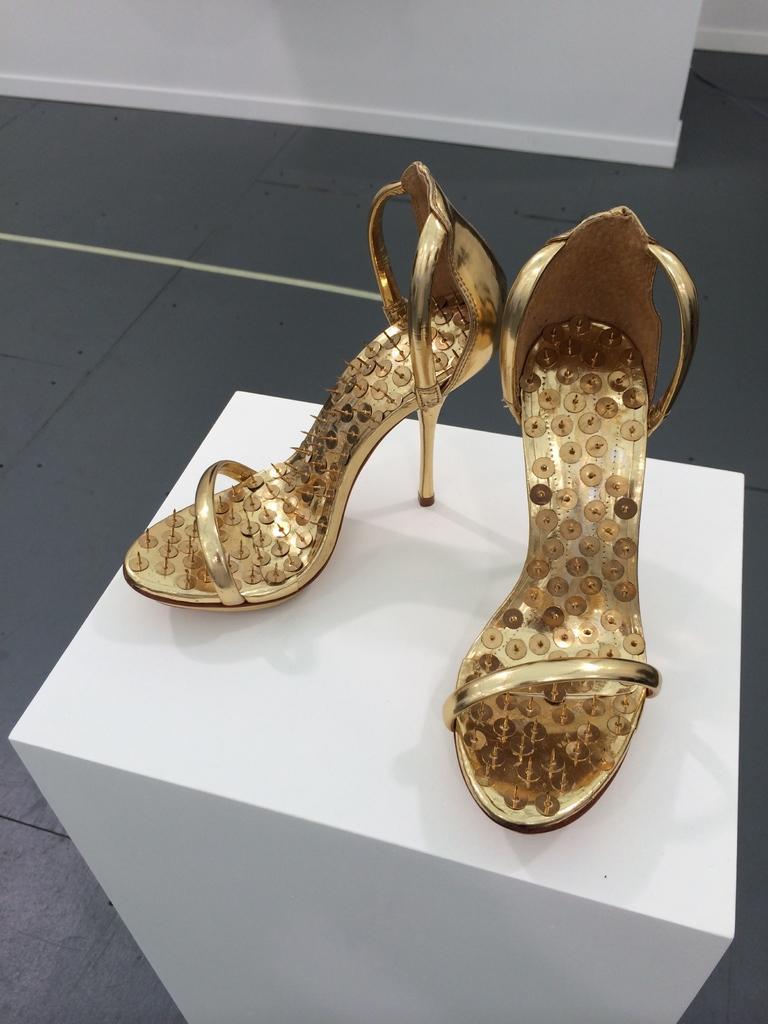Could you give a brief overview of what you see in this image? In this image I can see the footwear which are in brown color. These are on the white color surface. In the back I can see the grey color floor and the white wall. 